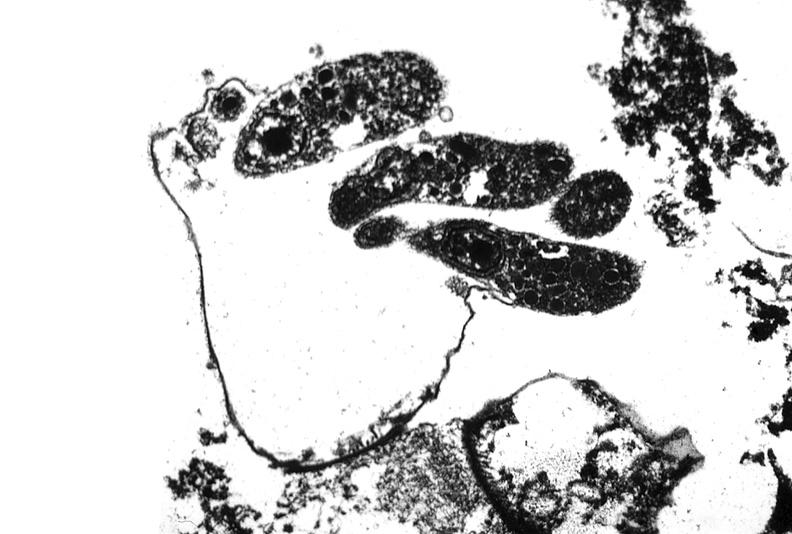s sickle cell disease present?
Answer the question using a single word or phrase. No 